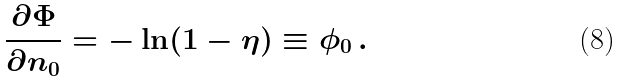<formula> <loc_0><loc_0><loc_500><loc_500>\frac { \partial \Phi } { \partial n _ { 0 } } = - \ln ( 1 - \eta ) \equiv \phi _ { 0 } \, .</formula> 